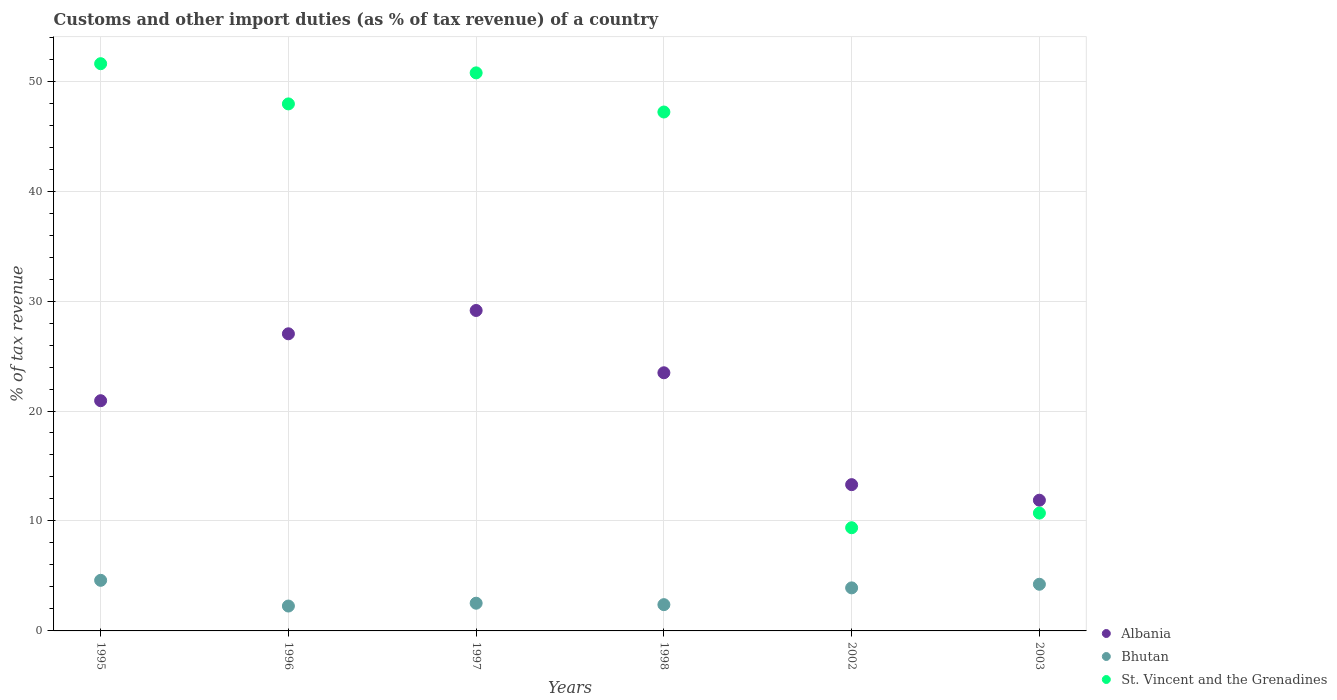Is the number of dotlines equal to the number of legend labels?
Make the answer very short. Yes. What is the percentage of tax revenue from customs in St. Vincent and the Grenadines in 1997?
Make the answer very short. 50.75. Across all years, what is the maximum percentage of tax revenue from customs in Bhutan?
Offer a terse response. 4.6. Across all years, what is the minimum percentage of tax revenue from customs in St. Vincent and the Grenadines?
Offer a very short reply. 9.38. In which year was the percentage of tax revenue from customs in Bhutan maximum?
Keep it short and to the point. 1995. In which year was the percentage of tax revenue from customs in St. Vincent and the Grenadines minimum?
Offer a very short reply. 2002. What is the total percentage of tax revenue from customs in Bhutan in the graph?
Offer a terse response. 19.93. What is the difference between the percentage of tax revenue from customs in Bhutan in 2002 and that in 2003?
Keep it short and to the point. -0.33. What is the difference between the percentage of tax revenue from customs in Albania in 2002 and the percentage of tax revenue from customs in Bhutan in 1996?
Give a very brief answer. 11.04. What is the average percentage of tax revenue from customs in Albania per year?
Offer a very short reply. 20.96. In the year 2002, what is the difference between the percentage of tax revenue from customs in Albania and percentage of tax revenue from customs in St. Vincent and the Grenadines?
Provide a succinct answer. 3.92. In how many years, is the percentage of tax revenue from customs in Bhutan greater than 22 %?
Provide a short and direct response. 0. What is the ratio of the percentage of tax revenue from customs in St. Vincent and the Grenadines in 1998 to that in 2002?
Provide a short and direct response. 5.03. Is the difference between the percentage of tax revenue from customs in Albania in 1995 and 2002 greater than the difference between the percentage of tax revenue from customs in St. Vincent and the Grenadines in 1995 and 2002?
Ensure brevity in your answer.  No. What is the difference between the highest and the second highest percentage of tax revenue from customs in Albania?
Provide a succinct answer. 2.12. What is the difference between the highest and the lowest percentage of tax revenue from customs in St. Vincent and the Grenadines?
Provide a short and direct response. 42.2. In how many years, is the percentage of tax revenue from customs in Bhutan greater than the average percentage of tax revenue from customs in Bhutan taken over all years?
Your answer should be very brief. 3. Is the percentage of tax revenue from customs in St. Vincent and the Grenadines strictly greater than the percentage of tax revenue from customs in Bhutan over the years?
Offer a terse response. Yes. Is the percentage of tax revenue from customs in Bhutan strictly less than the percentage of tax revenue from customs in St. Vincent and the Grenadines over the years?
Offer a terse response. Yes. What is the difference between two consecutive major ticks on the Y-axis?
Provide a succinct answer. 10. Are the values on the major ticks of Y-axis written in scientific E-notation?
Make the answer very short. No. Does the graph contain grids?
Your response must be concise. Yes. What is the title of the graph?
Your response must be concise. Customs and other import duties (as % of tax revenue) of a country. Does "Barbados" appear as one of the legend labels in the graph?
Your response must be concise. No. What is the label or title of the X-axis?
Offer a very short reply. Years. What is the label or title of the Y-axis?
Make the answer very short. % of tax revenue. What is the % of tax revenue in Albania in 1995?
Keep it short and to the point. 20.94. What is the % of tax revenue in Bhutan in 1995?
Keep it short and to the point. 4.6. What is the % of tax revenue of St. Vincent and the Grenadines in 1995?
Give a very brief answer. 51.59. What is the % of tax revenue of Albania in 1996?
Provide a succinct answer. 27.02. What is the % of tax revenue in Bhutan in 1996?
Your response must be concise. 2.26. What is the % of tax revenue of St. Vincent and the Grenadines in 1996?
Offer a very short reply. 47.93. What is the % of tax revenue in Albania in 1997?
Provide a succinct answer. 29.14. What is the % of tax revenue of Bhutan in 1997?
Keep it short and to the point. 2.52. What is the % of tax revenue in St. Vincent and the Grenadines in 1997?
Provide a succinct answer. 50.75. What is the % of tax revenue in Albania in 1998?
Your answer should be compact. 23.48. What is the % of tax revenue in Bhutan in 1998?
Make the answer very short. 2.39. What is the % of tax revenue of St. Vincent and the Grenadines in 1998?
Give a very brief answer. 47.19. What is the % of tax revenue of Albania in 2002?
Offer a terse response. 13.3. What is the % of tax revenue of Bhutan in 2002?
Make the answer very short. 3.91. What is the % of tax revenue in St. Vincent and the Grenadines in 2002?
Your answer should be very brief. 9.38. What is the % of tax revenue of Albania in 2003?
Give a very brief answer. 11.89. What is the % of tax revenue of Bhutan in 2003?
Make the answer very short. 4.24. What is the % of tax revenue in St. Vincent and the Grenadines in 2003?
Keep it short and to the point. 10.72. Across all years, what is the maximum % of tax revenue in Albania?
Your answer should be compact. 29.14. Across all years, what is the maximum % of tax revenue in Bhutan?
Your response must be concise. 4.6. Across all years, what is the maximum % of tax revenue in St. Vincent and the Grenadines?
Provide a succinct answer. 51.59. Across all years, what is the minimum % of tax revenue of Albania?
Your answer should be compact. 11.89. Across all years, what is the minimum % of tax revenue in Bhutan?
Make the answer very short. 2.26. Across all years, what is the minimum % of tax revenue in St. Vincent and the Grenadines?
Ensure brevity in your answer.  9.38. What is the total % of tax revenue of Albania in the graph?
Ensure brevity in your answer.  125.77. What is the total % of tax revenue of Bhutan in the graph?
Offer a terse response. 19.93. What is the total % of tax revenue in St. Vincent and the Grenadines in the graph?
Keep it short and to the point. 217.56. What is the difference between the % of tax revenue in Albania in 1995 and that in 1996?
Your answer should be very brief. -6.08. What is the difference between the % of tax revenue in Bhutan in 1995 and that in 1996?
Give a very brief answer. 2.34. What is the difference between the % of tax revenue in St. Vincent and the Grenadines in 1995 and that in 1996?
Your answer should be compact. 3.66. What is the difference between the % of tax revenue of Albania in 1995 and that in 1997?
Your answer should be compact. -8.21. What is the difference between the % of tax revenue in Bhutan in 1995 and that in 1997?
Keep it short and to the point. 2.08. What is the difference between the % of tax revenue in St. Vincent and the Grenadines in 1995 and that in 1997?
Provide a short and direct response. 0.83. What is the difference between the % of tax revenue in Albania in 1995 and that in 1998?
Your answer should be compact. -2.54. What is the difference between the % of tax revenue of Bhutan in 1995 and that in 1998?
Your answer should be compact. 2.21. What is the difference between the % of tax revenue in St. Vincent and the Grenadines in 1995 and that in 1998?
Offer a very short reply. 4.39. What is the difference between the % of tax revenue of Albania in 1995 and that in 2002?
Give a very brief answer. 7.63. What is the difference between the % of tax revenue of Bhutan in 1995 and that in 2002?
Your answer should be compact. 0.69. What is the difference between the % of tax revenue of St. Vincent and the Grenadines in 1995 and that in 2002?
Offer a very short reply. 42.2. What is the difference between the % of tax revenue in Albania in 1995 and that in 2003?
Your answer should be very brief. 9.05. What is the difference between the % of tax revenue in Bhutan in 1995 and that in 2003?
Keep it short and to the point. 0.36. What is the difference between the % of tax revenue of St. Vincent and the Grenadines in 1995 and that in 2003?
Your answer should be compact. 40.87. What is the difference between the % of tax revenue in Albania in 1996 and that in 1997?
Offer a very short reply. -2.12. What is the difference between the % of tax revenue of Bhutan in 1996 and that in 1997?
Offer a terse response. -0.26. What is the difference between the % of tax revenue of St. Vincent and the Grenadines in 1996 and that in 1997?
Give a very brief answer. -2.82. What is the difference between the % of tax revenue of Albania in 1996 and that in 1998?
Give a very brief answer. 3.54. What is the difference between the % of tax revenue of Bhutan in 1996 and that in 1998?
Keep it short and to the point. -0.13. What is the difference between the % of tax revenue of St. Vincent and the Grenadines in 1996 and that in 1998?
Make the answer very short. 0.74. What is the difference between the % of tax revenue in Albania in 1996 and that in 2002?
Keep it short and to the point. 13.72. What is the difference between the % of tax revenue in Bhutan in 1996 and that in 2002?
Provide a short and direct response. -1.65. What is the difference between the % of tax revenue of St. Vincent and the Grenadines in 1996 and that in 2002?
Offer a very short reply. 38.54. What is the difference between the % of tax revenue of Albania in 1996 and that in 2003?
Give a very brief answer. 15.13. What is the difference between the % of tax revenue of Bhutan in 1996 and that in 2003?
Provide a succinct answer. -1.98. What is the difference between the % of tax revenue in St. Vincent and the Grenadines in 1996 and that in 2003?
Provide a short and direct response. 37.21. What is the difference between the % of tax revenue of Albania in 1997 and that in 1998?
Your answer should be very brief. 5.66. What is the difference between the % of tax revenue of Bhutan in 1997 and that in 1998?
Your answer should be compact. 0.13. What is the difference between the % of tax revenue of St. Vincent and the Grenadines in 1997 and that in 1998?
Provide a short and direct response. 3.56. What is the difference between the % of tax revenue in Albania in 1997 and that in 2002?
Offer a terse response. 15.84. What is the difference between the % of tax revenue of Bhutan in 1997 and that in 2002?
Provide a succinct answer. -1.39. What is the difference between the % of tax revenue of St. Vincent and the Grenadines in 1997 and that in 2002?
Your answer should be very brief. 41.37. What is the difference between the % of tax revenue of Albania in 1997 and that in 2003?
Make the answer very short. 17.26. What is the difference between the % of tax revenue of Bhutan in 1997 and that in 2003?
Provide a succinct answer. -1.72. What is the difference between the % of tax revenue in St. Vincent and the Grenadines in 1997 and that in 2003?
Ensure brevity in your answer.  40.04. What is the difference between the % of tax revenue in Albania in 1998 and that in 2002?
Give a very brief answer. 10.18. What is the difference between the % of tax revenue of Bhutan in 1998 and that in 2002?
Offer a terse response. -1.53. What is the difference between the % of tax revenue of St. Vincent and the Grenadines in 1998 and that in 2002?
Ensure brevity in your answer.  37.81. What is the difference between the % of tax revenue in Albania in 1998 and that in 2003?
Offer a very short reply. 11.59. What is the difference between the % of tax revenue in Bhutan in 1998 and that in 2003?
Your response must be concise. -1.86. What is the difference between the % of tax revenue in St. Vincent and the Grenadines in 1998 and that in 2003?
Provide a short and direct response. 36.48. What is the difference between the % of tax revenue of Albania in 2002 and that in 2003?
Your response must be concise. 1.42. What is the difference between the % of tax revenue of Bhutan in 2002 and that in 2003?
Your response must be concise. -0.33. What is the difference between the % of tax revenue of St. Vincent and the Grenadines in 2002 and that in 2003?
Offer a terse response. -1.33. What is the difference between the % of tax revenue of Albania in 1995 and the % of tax revenue of Bhutan in 1996?
Ensure brevity in your answer.  18.67. What is the difference between the % of tax revenue of Albania in 1995 and the % of tax revenue of St. Vincent and the Grenadines in 1996?
Keep it short and to the point. -26.99. What is the difference between the % of tax revenue in Bhutan in 1995 and the % of tax revenue in St. Vincent and the Grenadines in 1996?
Provide a short and direct response. -43.33. What is the difference between the % of tax revenue of Albania in 1995 and the % of tax revenue of Bhutan in 1997?
Your answer should be very brief. 18.42. What is the difference between the % of tax revenue in Albania in 1995 and the % of tax revenue in St. Vincent and the Grenadines in 1997?
Provide a succinct answer. -29.81. What is the difference between the % of tax revenue in Bhutan in 1995 and the % of tax revenue in St. Vincent and the Grenadines in 1997?
Give a very brief answer. -46.15. What is the difference between the % of tax revenue in Albania in 1995 and the % of tax revenue in Bhutan in 1998?
Offer a terse response. 18.55. What is the difference between the % of tax revenue in Albania in 1995 and the % of tax revenue in St. Vincent and the Grenadines in 1998?
Offer a terse response. -26.25. What is the difference between the % of tax revenue in Bhutan in 1995 and the % of tax revenue in St. Vincent and the Grenadines in 1998?
Keep it short and to the point. -42.59. What is the difference between the % of tax revenue in Albania in 1995 and the % of tax revenue in Bhutan in 2002?
Ensure brevity in your answer.  17.02. What is the difference between the % of tax revenue in Albania in 1995 and the % of tax revenue in St. Vincent and the Grenadines in 2002?
Give a very brief answer. 11.55. What is the difference between the % of tax revenue of Bhutan in 1995 and the % of tax revenue of St. Vincent and the Grenadines in 2002?
Provide a succinct answer. -4.78. What is the difference between the % of tax revenue in Albania in 1995 and the % of tax revenue in Bhutan in 2003?
Make the answer very short. 16.69. What is the difference between the % of tax revenue in Albania in 1995 and the % of tax revenue in St. Vincent and the Grenadines in 2003?
Your answer should be very brief. 10.22. What is the difference between the % of tax revenue in Bhutan in 1995 and the % of tax revenue in St. Vincent and the Grenadines in 2003?
Make the answer very short. -6.11. What is the difference between the % of tax revenue of Albania in 1996 and the % of tax revenue of Bhutan in 1997?
Offer a very short reply. 24.5. What is the difference between the % of tax revenue of Albania in 1996 and the % of tax revenue of St. Vincent and the Grenadines in 1997?
Your response must be concise. -23.73. What is the difference between the % of tax revenue in Bhutan in 1996 and the % of tax revenue in St. Vincent and the Grenadines in 1997?
Ensure brevity in your answer.  -48.49. What is the difference between the % of tax revenue of Albania in 1996 and the % of tax revenue of Bhutan in 1998?
Keep it short and to the point. 24.63. What is the difference between the % of tax revenue in Albania in 1996 and the % of tax revenue in St. Vincent and the Grenadines in 1998?
Your answer should be compact. -20.17. What is the difference between the % of tax revenue in Bhutan in 1996 and the % of tax revenue in St. Vincent and the Grenadines in 1998?
Make the answer very short. -44.93. What is the difference between the % of tax revenue of Albania in 1996 and the % of tax revenue of Bhutan in 2002?
Your answer should be compact. 23.11. What is the difference between the % of tax revenue in Albania in 1996 and the % of tax revenue in St. Vincent and the Grenadines in 2002?
Give a very brief answer. 17.64. What is the difference between the % of tax revenue of Bhutan in 1996 and the % of tax revenue of St. Vincent and the Grenadines in 2002?
Provide a short and direct response. -7.12. What is the difference between the % of tax revenue of Albania in 1996 and the % of tax revenue of Bhutan in 2003?
Keep it short and to the point. 22.78. What is the difference between the % of tax revenue in Albania in 1996 and the % of tax revenue in St. Vincent and the Grenadines in 2003?
Make the answer very short. 16.31. What is the difference between the % of tax revenue in Bhutan in 1996 and the % of tax revenue in St. Vincent and the Grenadines in 2003?
Provide a succinct answer. -8.45. What is the difference between the % of tax revenue of Albania in 1997 and the % of tax revenue of Bhutan in 1998?
Make the answer very short. 26.75. What is the difference between the % of tax revenue in Albania in 1997 and the % of tax revenue in St. Vincent and the Grenadines in 1998?
Your answer should be compact. -18.05. What is the difference between the % of tax revenue of Bhutan in 1997 and the % of tax revenue of St. Vincent and the Grenadines in 1998?
Your answer should be very brief. -44.67. What is the difference between the % of tax revenue of Albania in 1997 and the % of tax revenue of Bhutan in 2002?
Offer a very short reply. 25.23. What is the difference between the % of tax revenue of Albania in 1997 and the % of tax revenue of St. Vincent and the Grenadines in 2002?
Offer a very short reply. 19.76. What is the difference between the % of tax revenue in Bhutan in 1997 and the % of tax revenue in St. Vincent and the Grenadines in 2002?
Your answer should be compact. -6.86. What is the difference between the % of tax revenue in Albania in 1997 and the % of tax revenue in Bhutan in 2003?
Keep it short and to the point. 24.9. What is the difference between the % of tax revenue in Albania in 1997 and the % of tax revenue in St. Vincent and the Grenadines in 2003?
Provide a short and direct response. 18.43. What is the difference between the % of tax revenue of Bhutan in 1997 and the % of tax revenue of St. Vincent and the Grenadines in 2003?
Provide a succinct answer. -8.2. What is the difference between the % of tax revenue of Albania in 1998 and the % of tax revenue of Bhutan in 2002?
Ensure brevity in your answer.  19.56. What is the difference between the % of tax revenue of Albania in 1998 and the % of tax revenue of St. Vincent and the Grenadines in 2002?
Your answer should be very brief. 14.09. What is the difference between the % of tax revenue in Bhutan in 1998 and the % of tax revenue in St. Vincent and the Grenadines in 2002?
Offer a very short reply. -7. What is the difference between the % of tax revenue in Albania in 1998 and the % of tax revenue in Bhutan in 2003?
Provide a short and direct response. 19.23. What is the difference between the % of tax revenue in Albania in 1998 and the % of tax revenue in St. Vincent and the Grenadines in 2003?
Provide a succinct answer. 12.76. What is the difference between the % of tax revenue in Bhutan in 1998 and the % of tax revenue in St. Vincent and the Grenadines in 2003?
Offer a very short reply. -8.33. What is the difference between the % of tax revenue in Albania in 2002 and the % of tax revenue in Bhutan in 2003?
Your response must be concise. 9.06. What is the difference between the % of tax revenue of Albania in 2002 and the % of tax revenue of St. Vincent and the Grenadines in 2003?
Offer a very short reply. 2.59. What is the difference between the % of tax revenue of Bhutan in 2002 and the % of tax revenue of St. Vincent and the Grenadines in 2003?
Offer a very short reply. -6.8. What is the average % of tax revenue in Albania per year?
Make the answer very short. 20.96. What is the average % of tax revenue of Bhutan per year?
Offer a terse response. 3.32. What is the average % of tax revenue in St. Vincent and the Grenadines per year?
Ensure brevity in your answer.  36.26. In the year 1995, what is the difference between the % of tax revenue of Albania and % of tax revenue of Bhutan?
Your answer should be very brief. 16.34. In the year 1995, what is the difference between the % of tax revenue of Albania and % of tax revenue of St. Vincent and the Grenadines?
Your answer should be compact. -30.65. In the year 1995, what is the difference between the % of tax revenue of Bhutan and % of tax revenue of St. Vincent and the Grenadines?
Your answer should be very brief. -46.98. In the year 1996, what is the difference between the % of tax revenue in Albania and % of tax revenue in Bhutan?
Provide a succinct answer. 24.76. In the year 1996, what is the difference between the % of tax revenue in Albania and % of tax revenue in St. Vincent and the Grenadines?
Your answer should be very brief. -20.91. In the year 1996, what is the difference between the % of tax revenue in Bhutan and % of tax revenue in St. Vincent and the Grenadines?
Your answer should be very brief. -45.67. In the year 1997, what is the difference between the % of tax revenue in Albania and % of tax revenue in Bhutan?
Give a very brief answer. 26.62. In the year 1997, what is the difference between the % of tax revenue in Albania and % of tax revenue in St. Vincent and the Grenadines?
Your response must be concise. -21.61. In the year 1997, what is the difference between the % of tax revenue of Bhutan and % of tax revenue of St. Vincent and the Grenadines?
Your answer should be compact. -48.23. In the year 1998, what is the difference between the % of tax revenue of Albania and % of tax revenue of Bhutan?
Offer a terse response. 21.09. In the year 1998, what is the difference between the % of tax revenue in Albania and % of tax revenue in St. Vincent and the Grenadines?
Provide a short and direct response. -23.71. In the year 1998, what is the difference between the % of tax revenue in Bhutan and % of tax revenue in St. Vincent and the Grenadines?
Your answer should be very brief. -44.8. In the year 2002, what is the difference between the % of tax revenue of Albania and % of tax revenue of Bhutan?
Offer a terse response. 9.39. In the year 2002, what is the difference between the % of tax revenue of Albania and % of tax revenue of St. Vincent and the Grenadines?
Keep it short and to the point. 3.92. In the year 2002, what is the difference between the % of tax revenue in Bhutan and % of tax revenue in St. Vincent and the Grenadines?
Ensure brevity in your answer.  -5.47. In the year 2003, what is the difference between the % of tax revenue of Albania and % of tax revenue of Bhutan?
Offer a very short reply. 7.64. In the year 2003, what is the difference between the % of tax revenue of Albania and % of tax revenue of St. Vincent and the Grenadines?
Offer a very short reply. 1.17. In the year 2003, what is the difference between the % of tax revenue of Bhutan and % of tax revenue of St. Vincent and the Grenadines?
Keep it short and to the point. -6.47. What is the ratio of the % of tax revenue in Albania in 1995 to that in 1996?
Your response must be concise. 0.77. What is the ratio of the % of tax revenue of Bhutan in 1995 to that in 1996?
Your answer should be very brief. 2.03. What is the ratio of the % of tax revenue of St. Vincent and the Grenadines in 1995 to that in 1996?
Offer a terse response. 1.08. What is the ratio of the % of tax revenue in Albania in 1995 to that in 1997?
Provide a short and direct response. 0.72. What is the ratio of the % of tax revenue of Bhutan in 1995 to that in 1997?
Keep it short and to the point. 1.83. What is the ratio of the % of tax revenue of St. Vincent and the Grenadines in 1995 to that in 1997?
Ensure brevity in your answer.  1.02. What is the ratio of the % of tax revenue in Albania in 1995 to that in 1998?
Give a very brief answer. 0.89. What is the ratio of the % of tax revenue of Bhutan in 1995 to that in 1998?
Make the answer very short. 1.93. What is the ratio of the % of tax revenue of St. Vincent and the Grenadines in 1995 to that in 1998?
Provide a succinct answer. 1.09. What is the ratio of the % of tax revenue of Albania in 1995 to that in 2002?
Offer a terse response. 1.57. What is the ratio of the % of tax revenue in Bhutan in 1995 to that in 2002?
Give a very brief answer. 1.18. What is the ratio of the % of tax revenue of St. Vincent and the Grenadines in 1995 to that in 2002?
Ensure brevity in your answer.  5.5. What is the ratio of the % of tax revenue in Albania in 1995 to that in 2003?
Make the answer very short. 1.76. What is the ratio of the % of tax revenue in Bhutan in 1995 to that in 2003?
Offer a very short reply. 1.08. What is the ratio of the % of tax revenue of St. Vincent and the Grenadines in 1995 to that in 2003?
Your answer should be very brief. 4.81. What is the ratio of the % of tax revenue in Albania in 1996 to that in 1997?
Ensure brevity in your answer.  0.93. What is the ratio of the % of tax revenue of Bhutan in 1996 to that in 1997?
Provide a short and direct response. 0.9. What is the ratio of the % of tax revenue of St. Vincent and the Grenadines in 1996 to that in 1997?
Offer a very short reply. 0.94. What is the ratio of the % of tax revenue in Albania in 1996 to that in 1998?
Keep it short and to the point. 1.15. What is the ratio of the % of tax revenue in Bhutan in 1996 to that in 1998?
Your answer should be compact. 0.95. What is the ratio of the % of tax revenue in St. Vincent and the Grenadines in 1996 to that in 1998?
Your answer should be very brief. 1.02. What is the ratio of the % of tax revenue of Albania in 1996 to that in 2002?
Your answer should be very brief. 2.03. What is the ratio of the % of tax revenue of Bhutan in 1996 to that in 2002?
Offer a terse response. 0.58. What is the ratio of the % of tax revenue of St. Vincent and the Grenadines in 1996 to that in 2002?
Provide a succinct answer. 5.11. What is the ratio of the % of tax revenue in Albania in 1996 to that in 2003?
Provide a short and direct response. 2.27. What is the ratio of the % of tax revenue of Bhutan in 1996 to that in 2003?
Provide a short and direct response. 0.53. What is the ratio of the % of tax revenue of St. Vincent and the Grenadines in 1996 to that in 2003?
Offer a terse response. 4.47. What is the ratio of the % of tax revenue of Albania in 1997 to that in 1998?
Your answer should be very brief. 1.24. What is the ratio of the % of tax revenue of Bhutan in 1997 to that in 1998?
Provide a short and direct response. 1.06. What is the ratio of the % of tax revenue of St. Vincent and the Grenadines in 1997 to that in 1998?
Offer a very short reply. 1.08. What is the ratio of the % of tax revenue in Albania in 1997 to that in 2002?
Your answer should be very brief. 2.19. What is the ratio of the % of tax revenue in Bhutan in 1997 to that in 2002?
Offer a terse response. 0.64. What is the ratio of the % of tax revenue of St. Vincent and the Grenadines in 1997 to that in 2002?
Offer a terse response. 5.41. What is the ratio of the % of tax revenue of Albania in 1997 to that in 2003?
Provide a succinct answer. 2.45. What is the ratio of the % of tax revenue in Bhutan in 1997 to that in 2003?
Offer a terse response. 0.59. What is the ratio of the % of tax revenue in St. Vincent and the Grenadines in 1997 to that in 2003?
Your answer should be compact. 4.74. What is the ratio of the % of tax revenue in Albania in 1998 to that in 2002?
Offer a terse response. 1.76. What is the ratio of the % of tax revenue in Bhutan in 1998 to that in 2002?
Keep it short and to the point. 0.61. What is the ratio of the % of tax revenue of St. Vincent and the Grenadines in 1998 to that in 2002?
Keep it short and to the point. 5.03. What is the ratio of the % of tax revenue in Albania in 1998 to that in 2003?
Your answer should be compact. 1.98. What is the ratio of the % of tax revenue in Bhutan in 1998 to that in 2003?
Your answer should be compact. 0.56. What is the ratio of the % of tax revenue in St. Vincent and the Grenadines in 1998 to that in 2003?
Your response must be concise. 4.4. What is the ratio of the % of tax revenue in Albania in 2002 to that in 2003?
Offer a very short reply. 1.12. What is the ratio of the % of tax revenue in Bhutan in 2002 to that in 2003?
Your response must be concise. 0.92. What is the ratio of the % of tax revenue in St. Vincent and the Grenadines in 2002 to that in 2003?
Offer a terse response. 0.88. What is the difference between the highest and the second highest % of tax revenue in Albania?
Provide a short and direct response. 2.12. What is the difference between the highest and the second highest % of tax revenue in Bhutan?
Keep it short and to the point. 0.36. What is the difference between the highest and the second highest % of tax revenue in St. Vincent and the Grenadines?
Your answer should be very brief. 0.83. What is the difference between the highest and the lowest % of tax revenue in Albania?
Give a very brief answer. 17.26. What is the difference between the highest and the lowest % of tax revenue of Bhutan?
Your response must be concise. 2.34. What is the difference between the highest and the lowest % of tax revenue in St. Vincent and the Grenadines?
Your response must be concise. 42.2. 